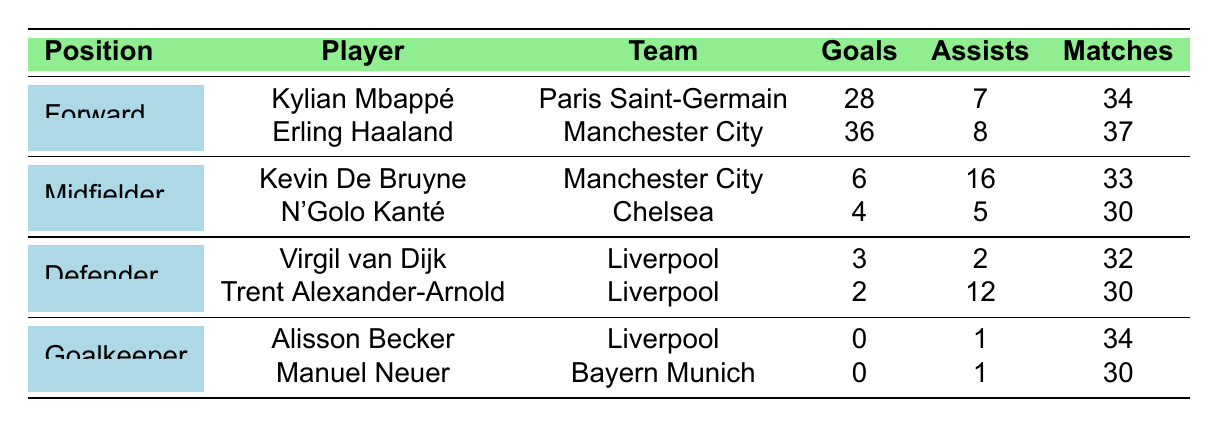What is the total number of goals scored by all forwards? To find the total number of goals scored by all forwards, we look at the goals column for the players in the Forward position: Kylian Mbappé has 28 goals and Erling Haaland has 36 goals. Adding these together gives us 28 + 36 = 64.
Answer: 64 Which midfielder assisted the most goals? In the midfielders' section, we check the assists column: Kevin De Bruyne has 16 assists and N'Golo Kanté has 5. Since 16 is greater than 5, Kevin De Bruyne assisted the most goals.
Answer: Kevin De Bruyne How many matches did Erling Haaland play this season? Referring to the table under the Forward section, Erling Haaland's matches played is directly listed as 37.
Answer: 37 What is the average number of assists by midfielders? The total assists by the midfielders are: Kevin De Bruyne has 16 and N'Golo Kanté has 5, summing up to 21 assists. There are 2 midfielders, so the average is 21/2 = 10.5.
Answer: 10.5 Did any goalkeeper score a goal this season? Referring to the Goalkeeper section, both Alisson Becker and Manuel Neuer have 0 goals. Thus, no goalkeeper scored a goal.
Answer: No What is the total contribution (goals + assists) of Kylian Mbappé? Kylian Mbappé has 28 goals and 7 assists. To find the total contribution, we sum these: 28 + 7 = 35.
Answer: 35 Which player has the highest goal contribution from goals and assists among all players? We calculate the total contribution for each player: Kylian Mbappé (28 + 7 = 35), Erling Haaland (36 + 8 = 44), Kevin De Bruyne (6 + 16 = 22), N'Golo Kanté (4 + 5 = 9), Virgil van Dijk (3 + 2 = 5), Trent Alexander-Arnold (2 + 12 = 14), Alisson Becker (0 + 1 = 1), Manuel Neuer (0 + 1 = 1). Erling Haaland has the highest total of 44.
Answer: Erling Haaland What’s the total goals scored by players in the Defender position? For defenders, Virgil van Dijk scored 3 goals and Trent Alexander-Arnold scored 2 goals. Adding these together gives 3 + 2 = 5 goals.
Answer: 5 Which team had the most goal contributions in the table? We add contributions for each team: Paris Saint-Germain (Kylian Mbappé: 35), Manchester City (Erling Haaland: 44 + Kevin De Bruyne: 22 = 66), Chelsea (N'Golo Kanté: 9), Liverpool (Virgil van Dijk: 5 + Trent Alexander-Arnold: 14 + Alisson Becker: 1 = 20), Bayern Munich (Manuel Neuer: 1). The total contributions show Manchester City with the highest at 66.
Answer: Manchester City What percentage of matches did Kylian Mbappé's assists represent (to the nearest whole number)? Kylian Mbappé has 7 assists, and he played 34 matches. To find the percentage, we calculate (7/34) * 100, which is approximately 20.59%, rounded to 21%.
Answer: 21% 